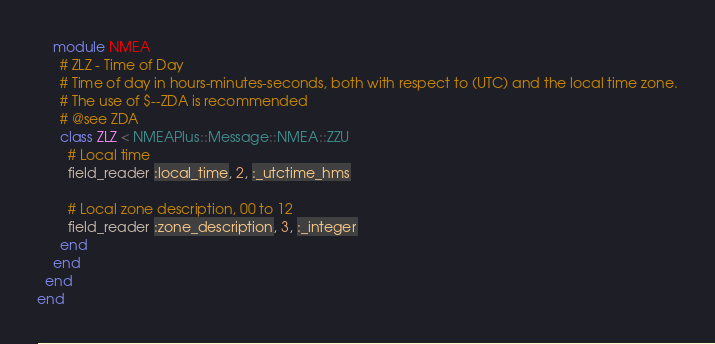<code> <loc_0><loc_0><loc_500><loc_500><_Ruby_>    module NMEA
      # ZLZ - Time of Day
      # Time of day in hours-minutes-seconds, both with respect to (UTC) and the local time zone.
      # The use of $--ZDA is recommended
      # @see ZDA
      class ZLZ < NMEAPlus::Message::NMEA::ZZU
        # Local time
        field_reader :local_time, 2, :_utctime_hms

        # Local zone description, 00 to 12
        field_reader :zone_description, 3, :_integer
      end
    end
  end
end
</code> 